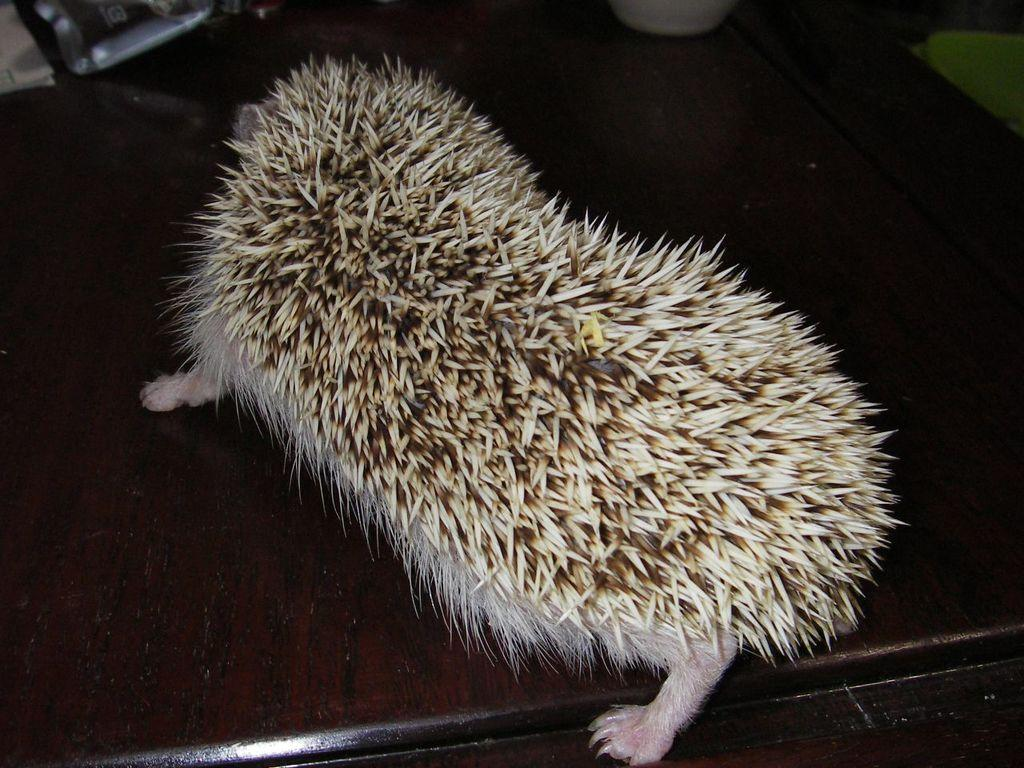What animal is the main subject of the image? There is a porcupine in the image. What is the porcupine resting on in the image? The porcupine is on a brown surface. What colors can be seen on the porcupine's body? The porcupine has white, cream, and brown coloring. How many cars can be seen in the image? There are no cars present in the image; it features a porcupine on a brown surface. What type of harmony is being depicted in the image? The image does not depict any harmony, as it is a close-up of a porcupine on a brown surface. 